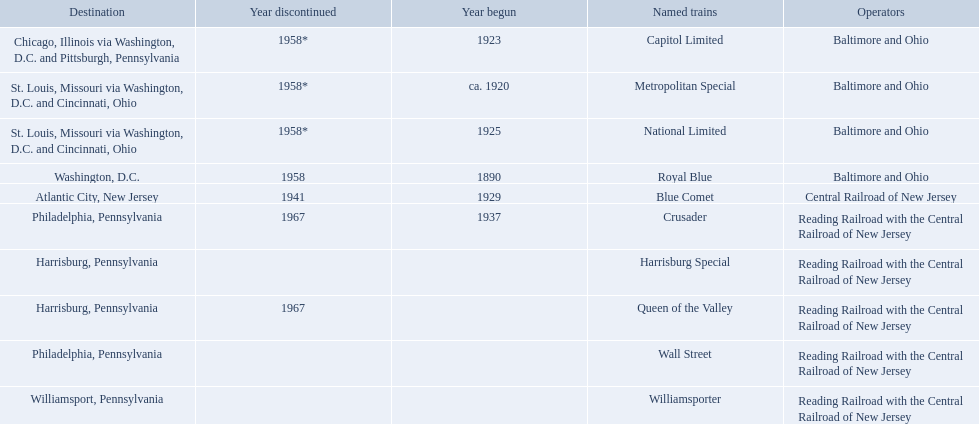What destinations are listed from the central railroad of new jersey terminal? Chicago, Illinois via Washington, D.C. and Pittsburgh, Pennsylvania, St. Louis, Missouri via Washington, D.C. and Cincinnati, Ohio, St. Louis, Missouri via Washington, D.C. and Cincinnati, Ohio, Washington, D.C., Atlantic City, New Jersey, Philadelphia, Pennsylvania, Harrisburg, Pennsylvania, Harrisburg, Pennsylvania, Philadelphia, Pennsylvania, Williamsport, Pennsylvania. Which of these destinations is listed first? Chicago, Illinois via Washington, D.C. and Pittsburgh, Pennsylvania. 